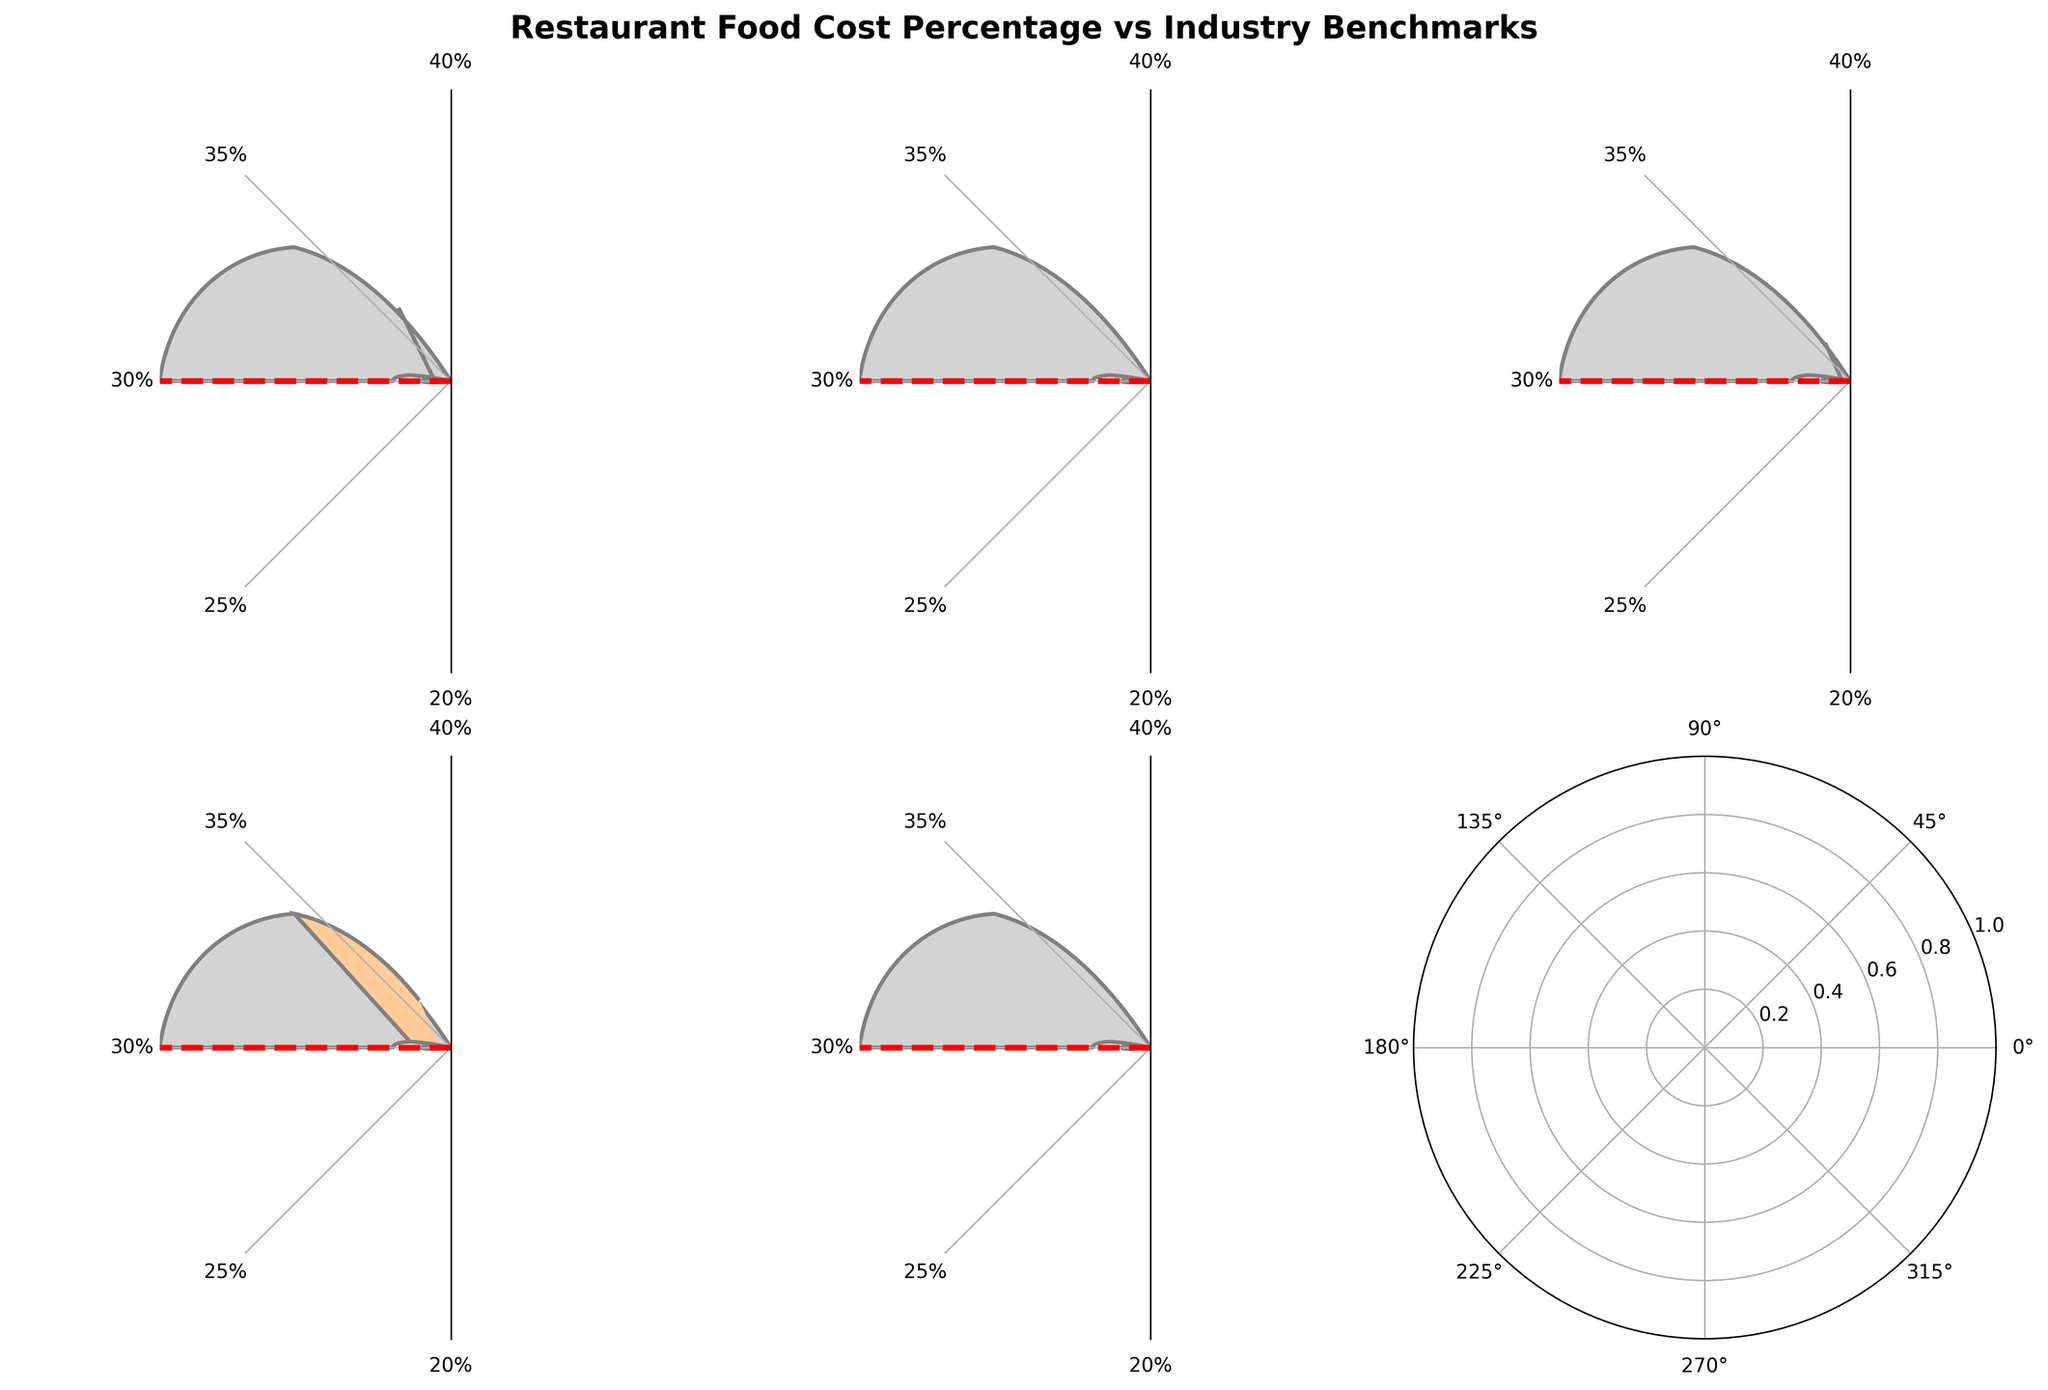What is the title of the figure? The title is displayed at the top of the figure.
Answer: Restaurant Food Cost Percentage vs Industry Benchmarks Which category has the highest food cost percentage? By examining all the gauges, the one showing the highest value is for Fine Dining, indicated at 35%.
Answer: Fine Dining How does your restaurant's food cost percentage compare to the industry benchmark? By looking at the gauge for "Your Restaurant", it shows a percentage of 32% while the benchmark is 30%.
Answer: 32% vs 30% What are the food cost percentages for Casual Dining and Fast Food? The gauges for Casual Dining and Fast Food show 31% and 28%, respectively.
Answer: Casual Dining: 31%, Fast Food: 28% Is your restaurant's food cost above or below the industry average? Your restaurant shows a food cost of 32%, while the industry average benchmark is 30%, indicating it is above.
Answer: Above By how much does the Fine Dining food cost percentage exceed the benchmark? The Fine Dining food cost is 35%; the benchmark is 30%, so the difference is 35% - 30% = 5%.
Answer: 5% Which categories fall below the industry average food cost percentage? The Fast Food category has a food cost of 28%, which is below the industry average of 30%.
Answer: Fast Food Calculate the average food cost percentage of your restaurant and Casual Dining combined. Add the percentages of your restaurant and Casual Dining (32% + 31%) and divide by 2. (32 + 31) / 2 = 31.5%.
Answer: 31.5% Which category's food cost percentage is closest to the benchmark? By comparing all categories, the Casual Dining's food cost percentage of 31% is closest to the benchmark of 30%.
Answer: Casual Dining Explain the difference between the highest and lowest food cost percentages. The highest food cost is for Fine Dining at 35%, and the lowest is for Fast Food at 28%. The difference is 35% - 28% = 7%.
Answer: 7% 